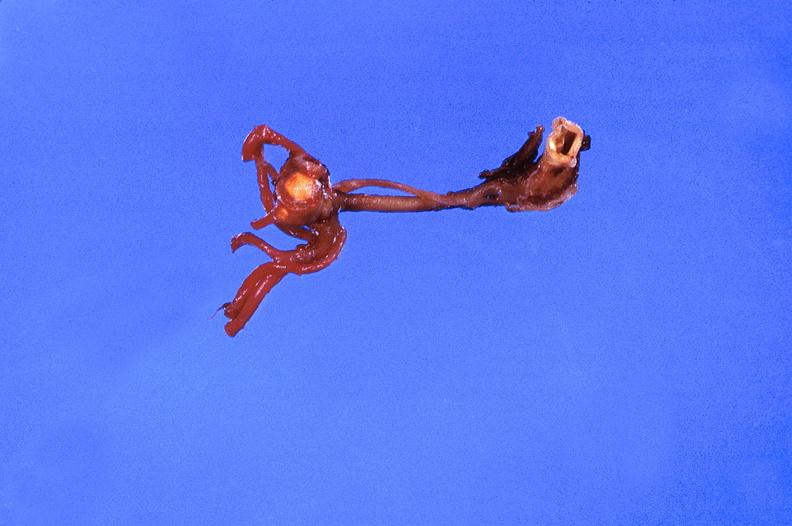where is this?
Answer the question using a single word or phrase. Vasculature 